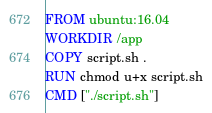Convert code to text. <code><loc_0><loc_0><loc_500><loc_500><_Dockerfile_>FROM ubuntu:16.04
WORKDIR /app
COPY script.sh .
RUN chmod u+x script.sh
CMD ["./script.sh"]</code> 